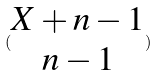<formula> <loc_0><loc_0><loc_500><loc_500>( \begin{matrix} X + n - 1 \\ n - 1 \end{matrix} )</formula> 